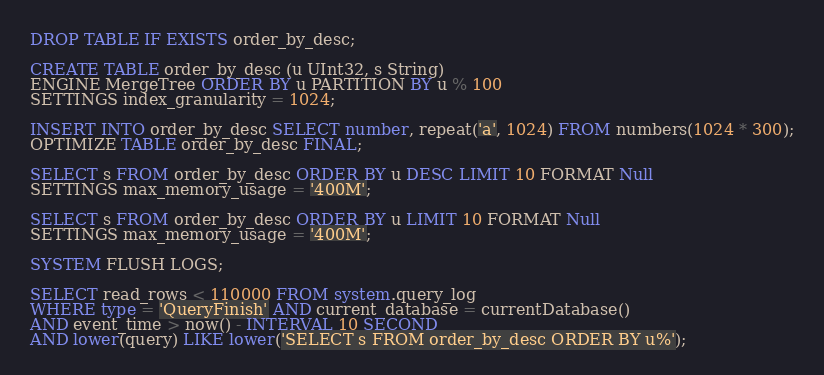Convert code to text. <code><loc_0><loc_0><loc_500><loc_500><_SQL_>DROP TABLE IF EXISTS order_by_desc;

CREATE TABLE order_by_desc (u UInt32, s String)
ENGINE MergeTree ORDER BY u PARTITION BY u % 100
SETTINGS index_granularity = 1024;

INSERT INTO order_by_desc SELECT number, repeat('a', 1024) FROM numbers(1024 * 300);
OPTIMIZE TABLE order_by_desc FINAL;

SELECT s FROM order_by_desc ORDER BY u DESC LIMIT 10 FORMAT Null
SETTINGS max_memory_usage = '400M';

SELECT s FROM order_by_desc ORDER BY u LIMIT 10 FORMAT Null
SETTINGS max_memory_usage = '400M';

SYSTEM FLUSH LOGS;

SELECT read_rows < 110000 FROM system.query_log
WHERE type = 'QueryFinish' AND current_database = currentDatabase()
AND event_time > now() - INTERVAL 10 SECOND
AND lower(query) LIKE lower('SELECT s FROM order_by_desc ORDER BY u%');
</code> 